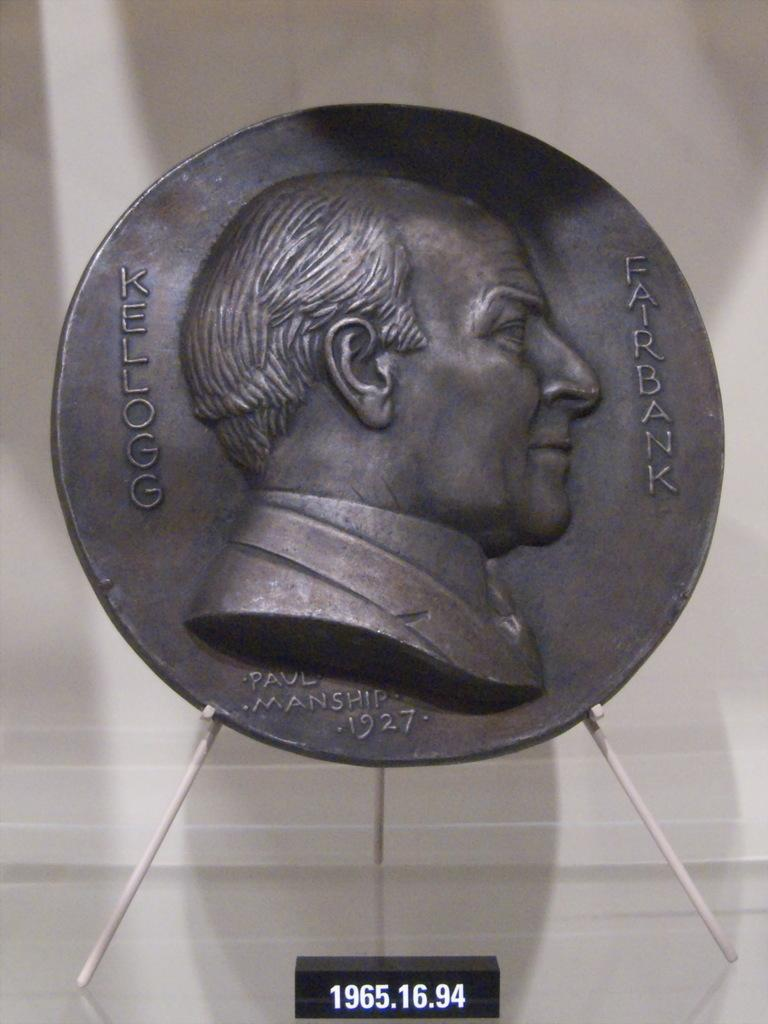<image>
Provide a brief description of the given image. Dark coin with a face on it and the words Kellogg Fairbank on it as well. 